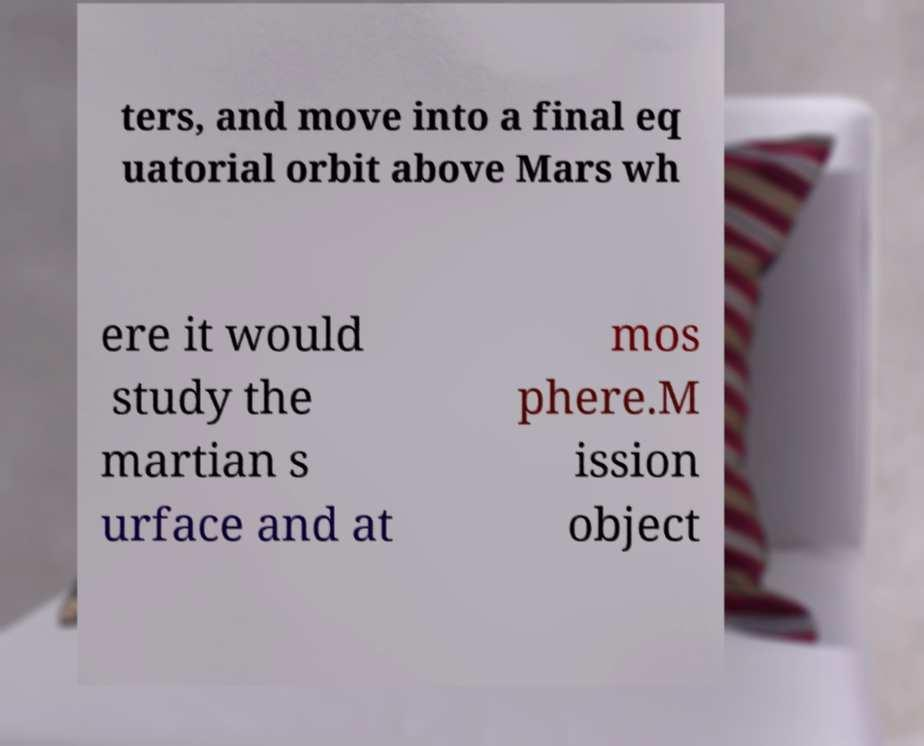I need the written content from this picture converted into text. Can you do that? ters, and move into a final eq uatorial orbit above Mars wh ere it would study the martian s urface and at mos phere.M ission object 